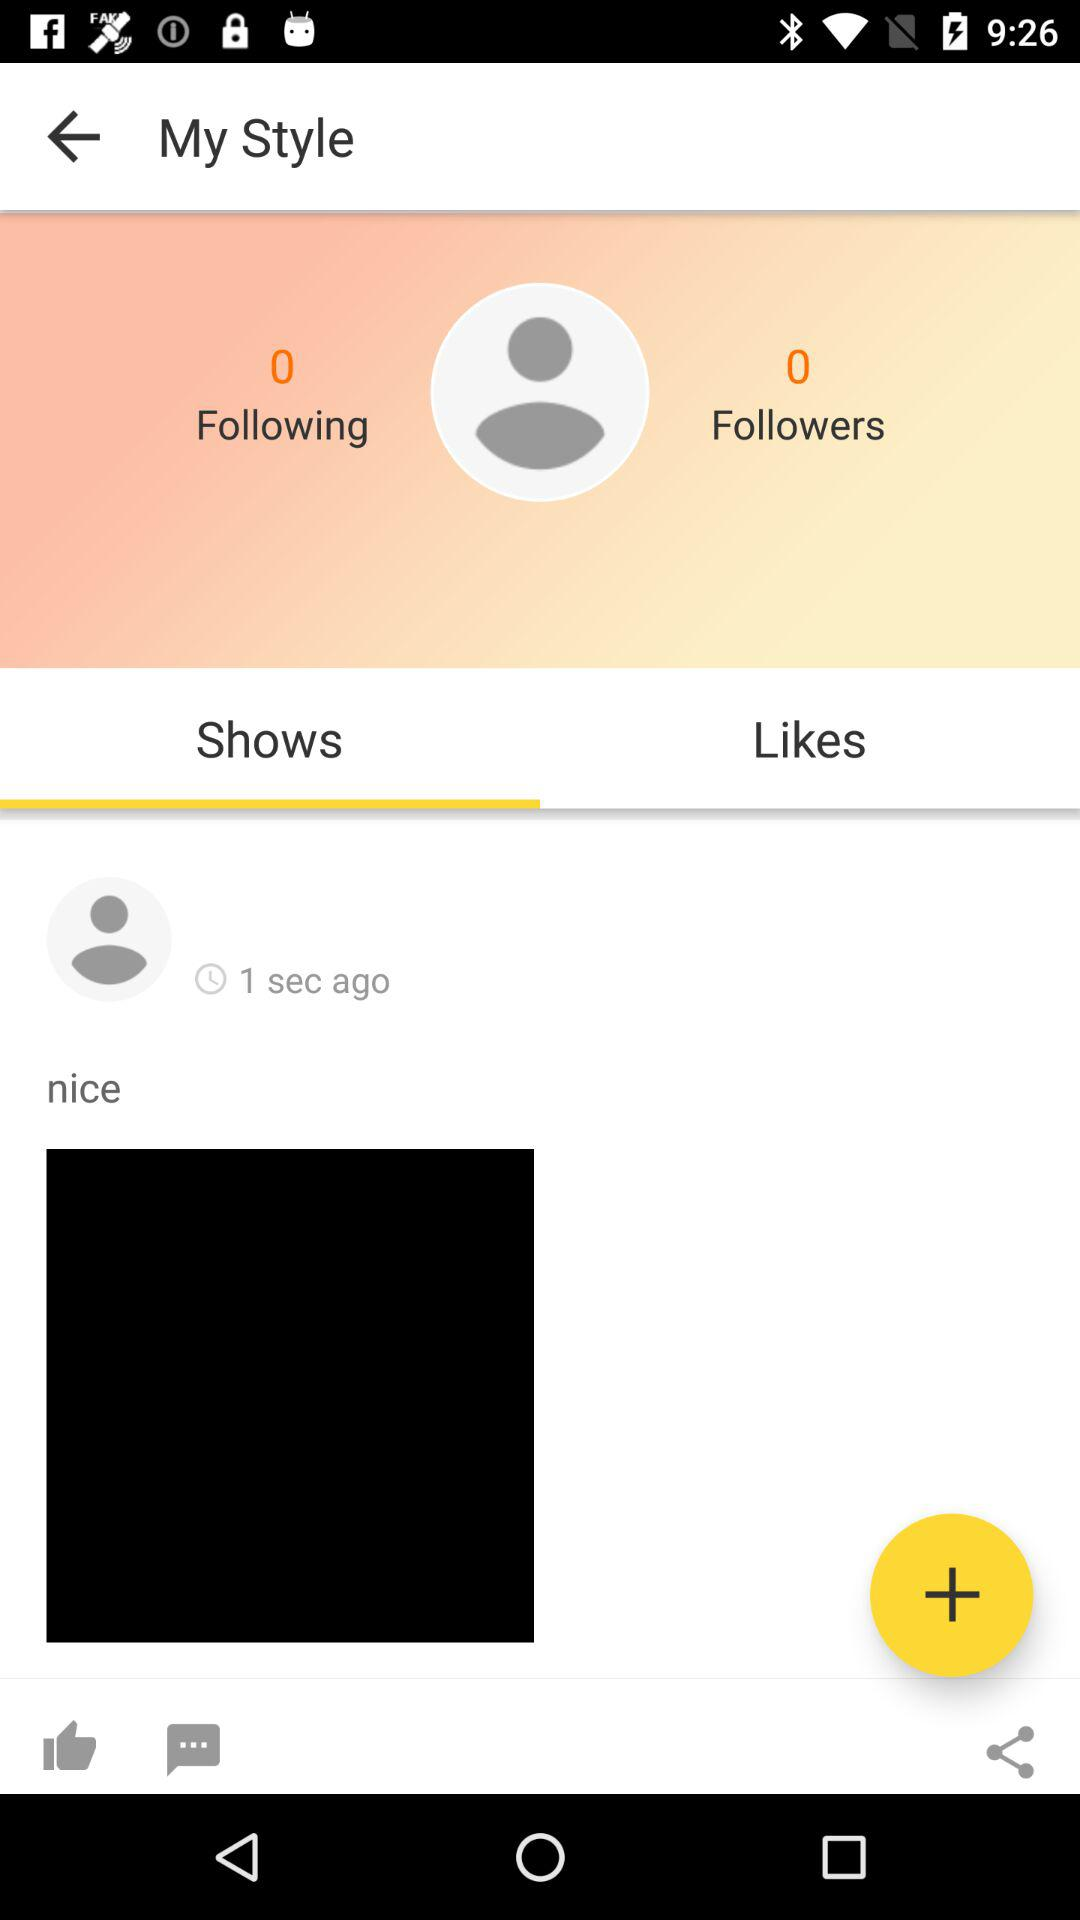Which option is selected? The selected option is "Shows". 